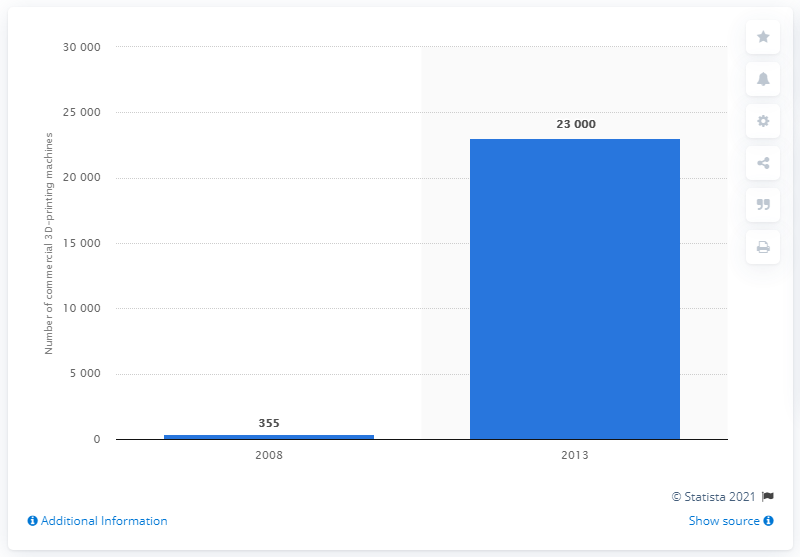Mention a couple of crucial points in this snapshot. The first commercial 3D printing machines were used in 2008. 